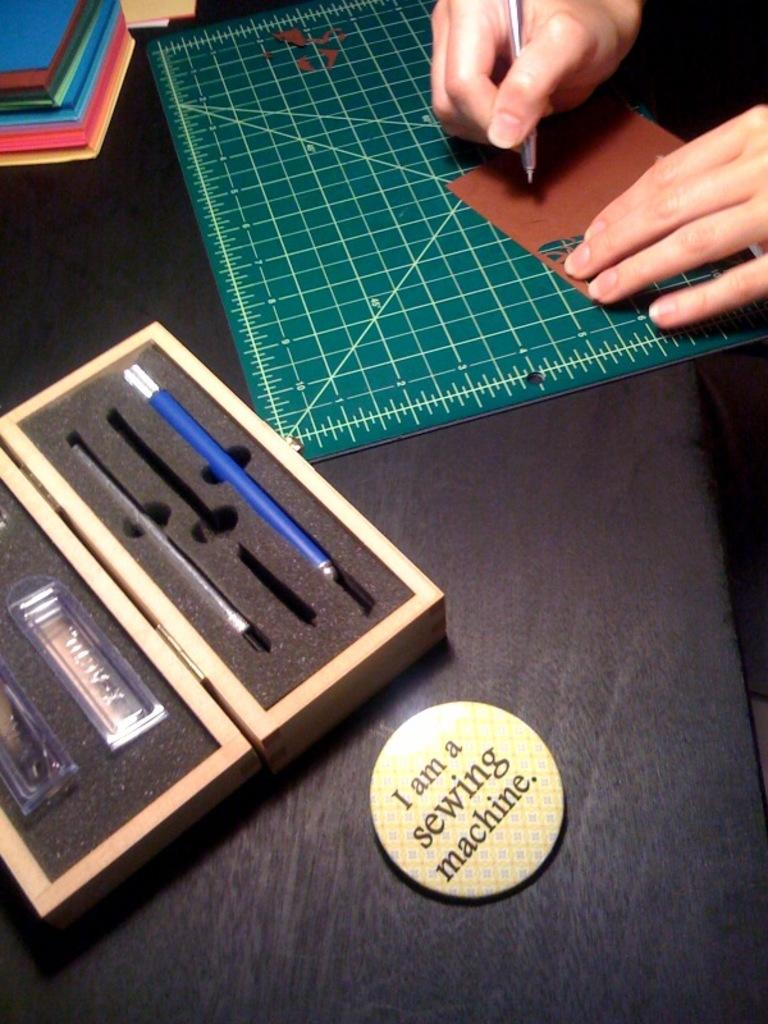<image>
Create a compact narrative representing the image presented. A button that reads I am a sewing machine sits on a table. 